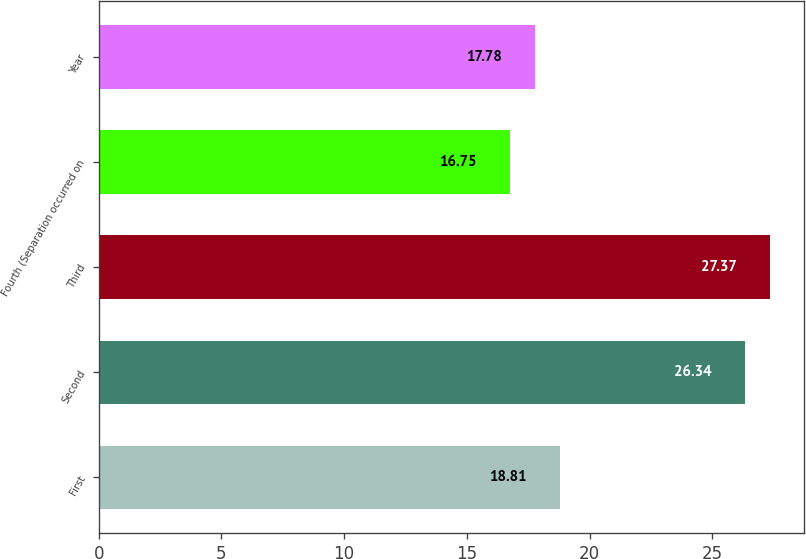Convert chart to OTSL. <chart><loc_0><loc_0><loc_500><loc_500><bar_chart><fcel>First<fcel>Second<fcel>Third<fcel>Fourth (Separation occurred on<fcel>Year<nl><fcel>18.81<fcel>26.34<fcel>27.37<fcel>16.75<fcel>17.78<nl></chart> 